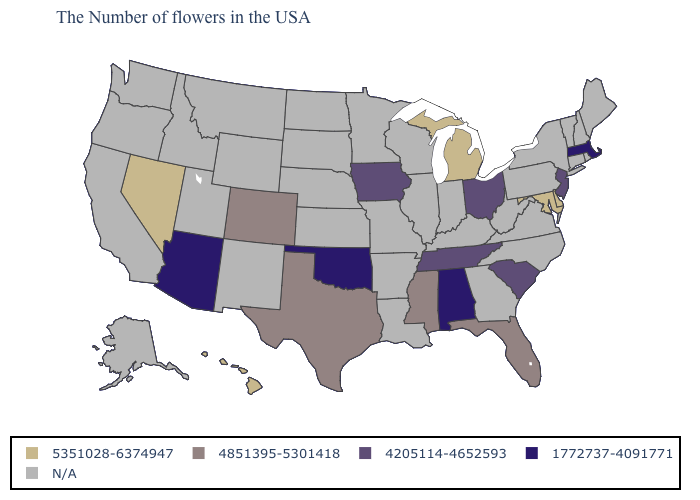Name the states that have a value in the range 4851395-5301418?
Be succinct. Florida, Mississippi, Texas, Colorado. What is the value of Washington?
Concise answer only. N/A. What is the value of Oregon?
Short answer required. N/A. Name the states that have a value in the range N/A?
Short answer required. Maine, Rhode Island, New Hampshire, Vermont, Connecticut, New York, Pennsylvania, Virginia, North Carolina, West Virginia, Georgia, Kentucky, Indiana, Wisconsin, Illinois, Louisiana, Missouri, Arkansas, Minnesota, Kansas, Nebraska, South Dakota, North Dakota, Wyoming, New Mexico, Utah, Montana, Idaho, California, Washington, Oregon, Alaska. Name the states that have a value in the range 5351028-6374947?
Give a very brief answer. Delaware, Maryland, Michigan, Nevada, Hawaii. Name the states that have a value in the range 4205114-4652593?
Short answer required. New Jersey, South Carolina, Ohio, Tennessee, Iowa. Does Ohio have the lowest value in the MidWest?
Quick response, please. Yes. What is the value of Texas?
Write a very short answer. 4851395-5301418. What is the value of South Carolina?
Give a very brief answer. 4205114-4652593. Which states have the highest value in the USA?
Write a very short answer. Delaware, Maryland, Michigan, Nevada, Hawaii. What is the highest value in the West ?
Concise answer only. 5351028-6374947. Does Alabama have the lowest value in the South?
Write a very short answer. Yes. What is the value of Vermont?
Keep it brief. N/A. Name the states that have a value in the range 1772737-4091771?
Keep it brief. Massachusetts, Alabama, Oklahoma, Arizona. Name the states that have a value in the range 4851395-5301418?
Concise answer only. Florida, Mississippi, Texas, Colorado. 